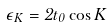<formula> <loc_0><loc_0><loc_500><loc_500>\epsilon _ { K } = 2 t _ { 0 } \cos K</formula> 